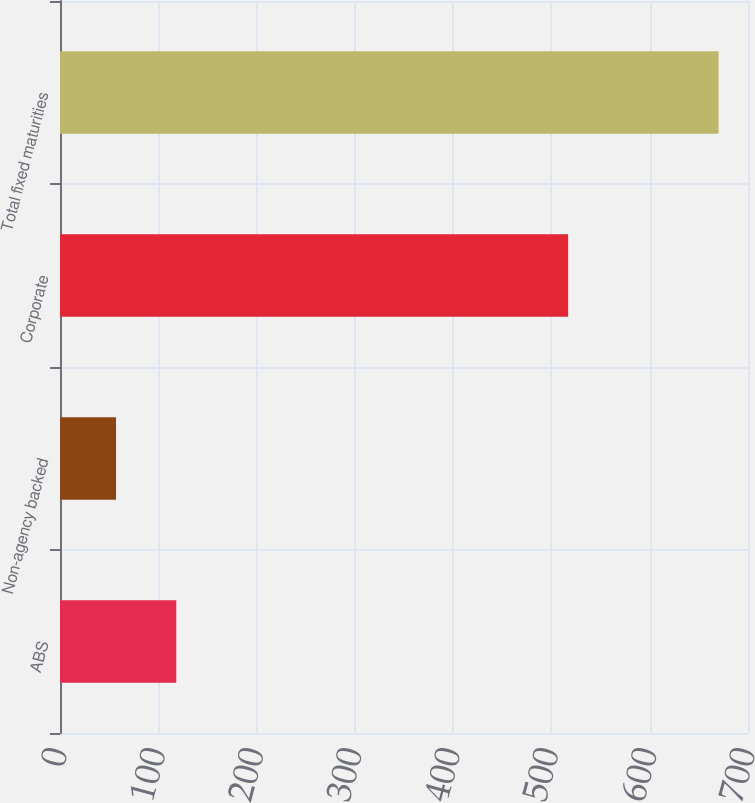Convert chart to OTSL. <chart><loc_0><loc_0><loc_500><loc_500><bar_chart><fcel>ABS<fcel>Non-agency backed<fcel>Corporate<fcel>Total fixed maturities<nl><fcel>118.3<fcel>57<fcel>517<fcel>670<nl></chart> 